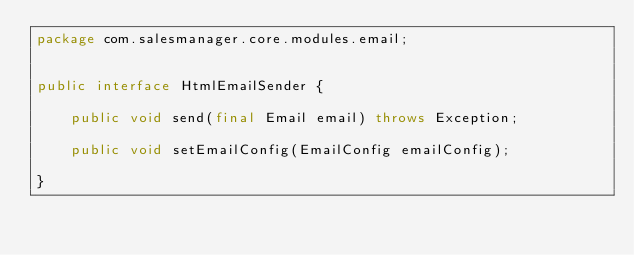<code> <loc_0><loc_0><loc_500><loc_500><_Java_>package com.salesmanager.core.modules.email;


public interface HtmlEmailSender {
	
	public void send(final Email email) throws Exception;

	public void setEmailConfig(EmailConfig emailConfig);

}
</code> 